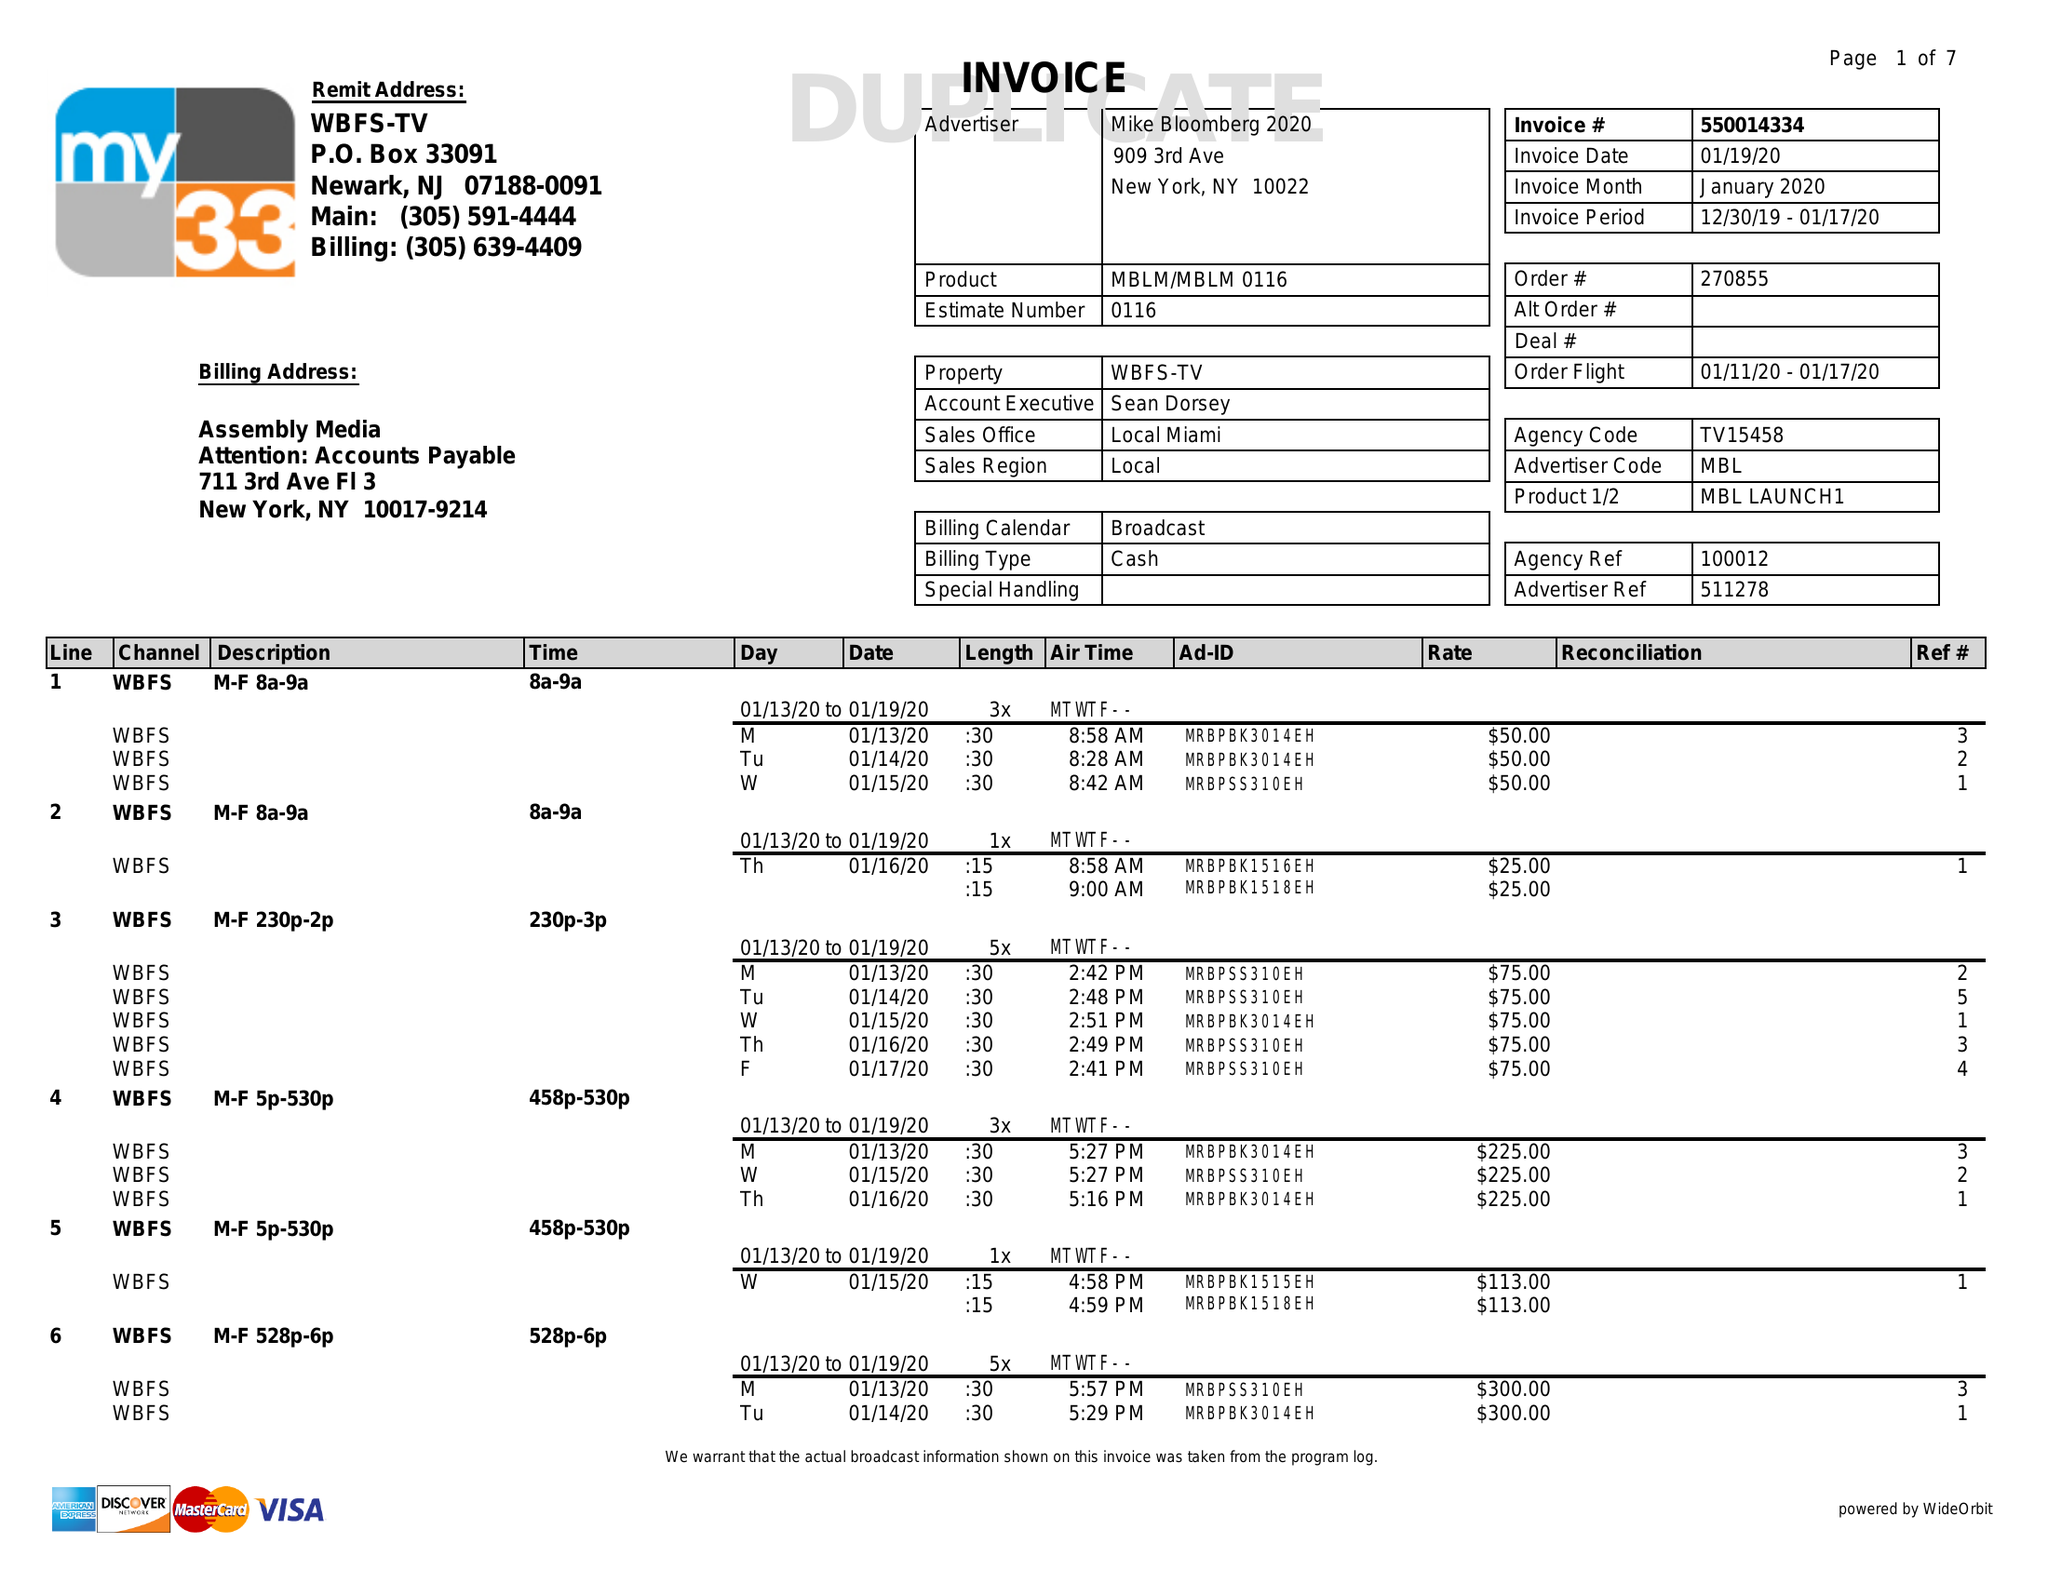What is the value for the flight_from?
Answer the question using a single word or phrase. 01/11/20 